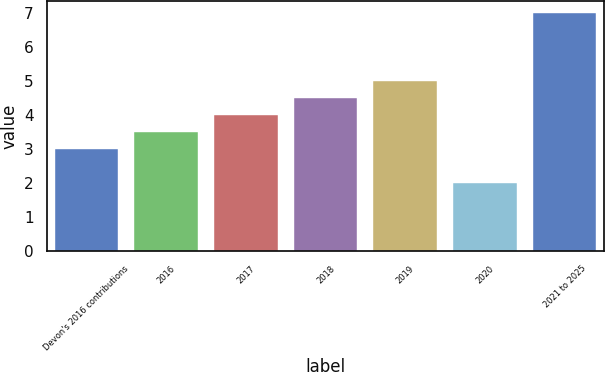Convert chart to OTSL. <chart><loc_0><loc_0><loc_500><loc_500><bar_chart><fcel>Devon's 2016 contributions<fcel>2016<fcel>2017<fcel>2018<fcel>2019<fcel>2020<fcel>2021 to 2025<nl><fcel>3<fcel>3.5<fcel>4<fcel>4.5<fcel>5<fcel>2<fcel>7<nl></chart> 